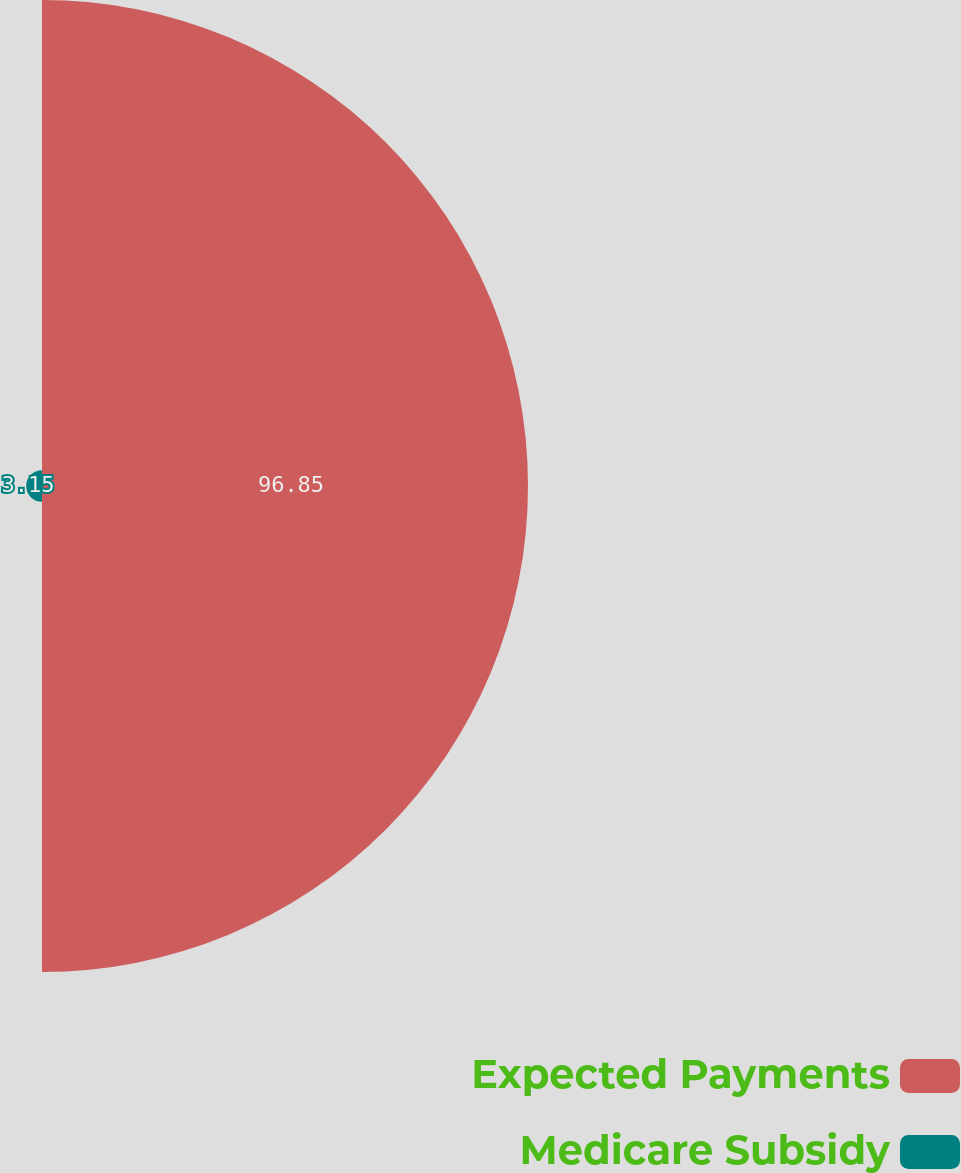Convert chart. <chart><loc_0><loc_0><loc_500><loc_500><pie_chart><fcel>Expected Payments<fcel>Medicare Subsidy<nl><fcel>96.85%<fcel>3.15%<nl></chart> 